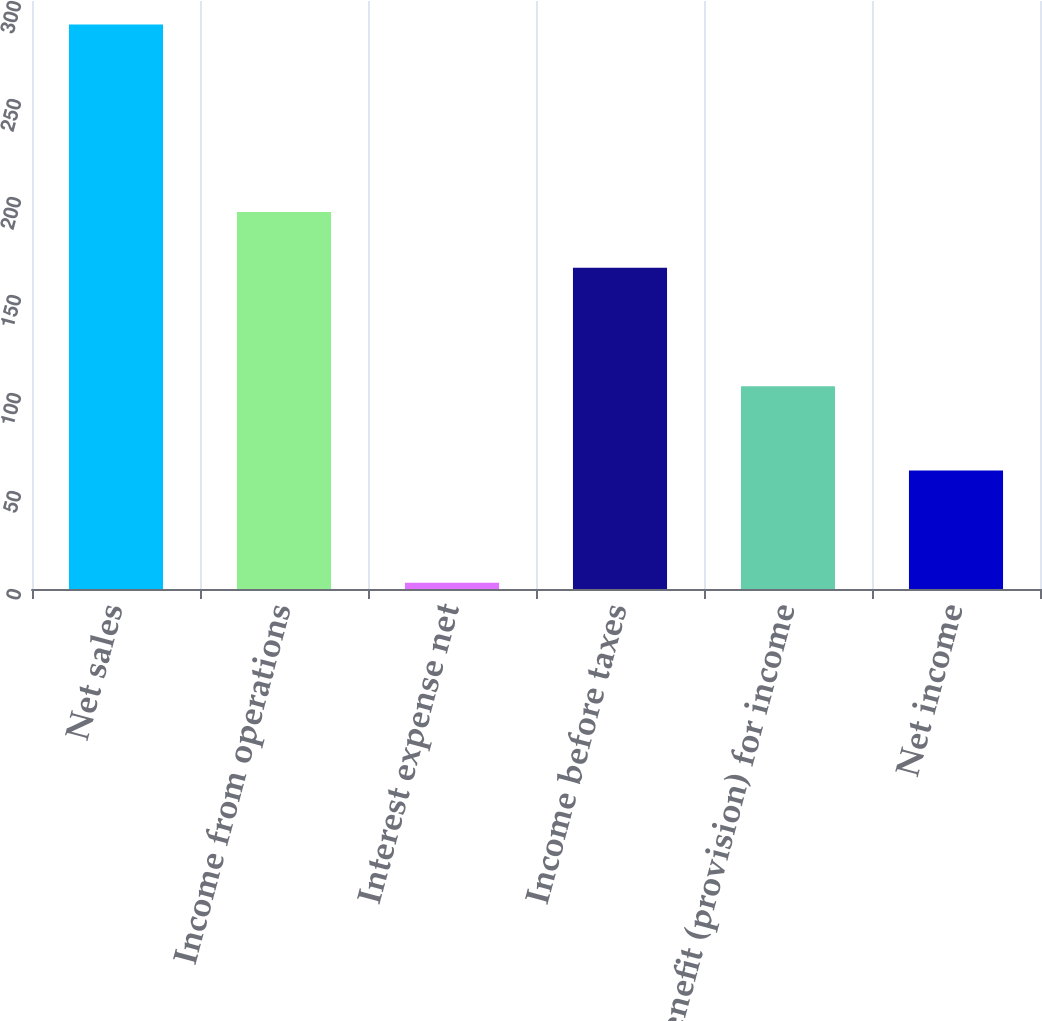Convert chart. <chart><loc_0><loc_0><loc_500><loc_500><bar_chart><fcel>Net sales<fcel>Income from operations<fcel>Interest expense net<fcel>Income before taxes<fcel>Benefit (provision) for income<fcel>Net income<nl><fcel>288<fcel>192.38<fcel>3.2<fcel>163.9<fcel>103.4<fcel>60.5<nl></chart> 